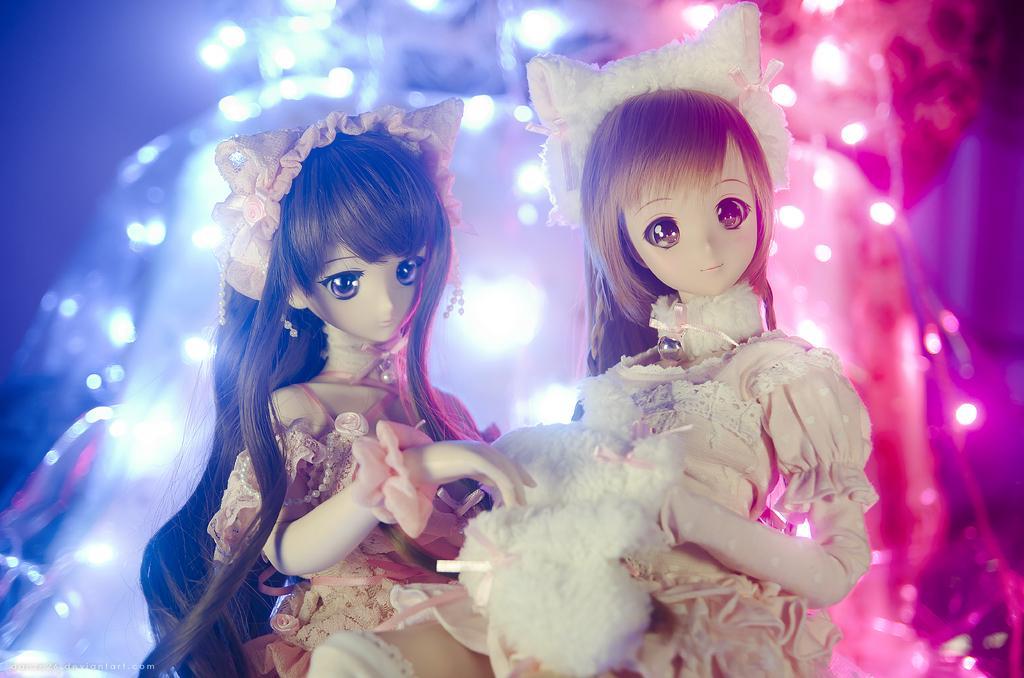In one or two sentences, can you explain what this image depicts? In the center of the image there are dolls. In the background of the image there are lights. 